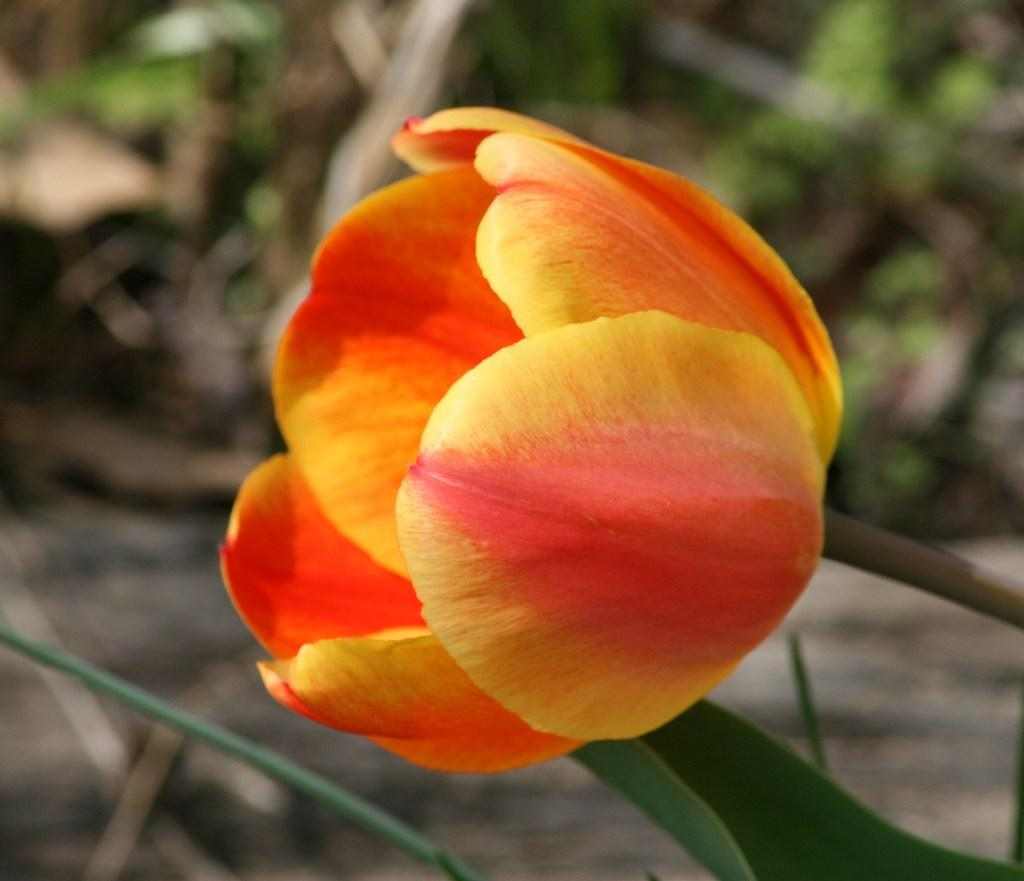What type of flower is in the foreground of the image? There is an orange color flower in the foreground of the image. What other element can be seen at the bottom of the image? There is a leaf at the bottom of the image. How would you describe the background of the image? The background of the image is blurred. Where is the playground located in the image? There is no playground present in the image. What type of fuel is being used by the flower in the image? The flower does not use fuel; it is a living organism that obtains nutrients through its roots and photosynthesis. 